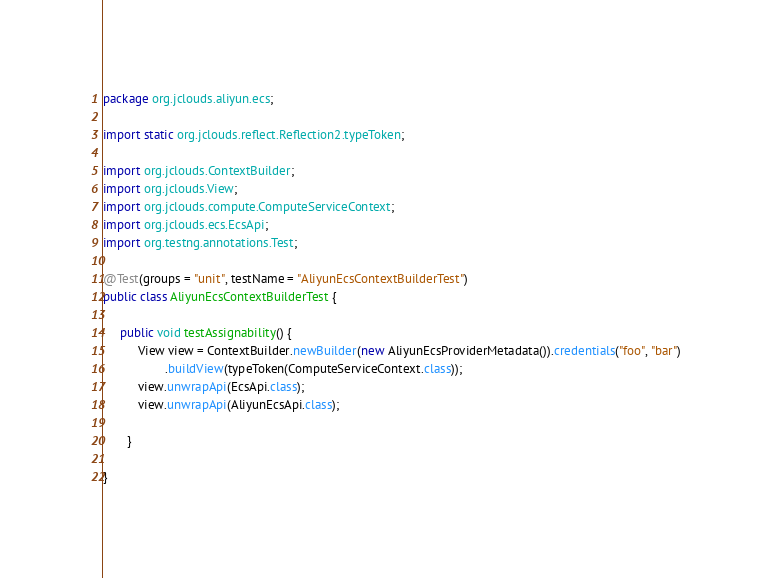Convert code to text. <code><loc_0><loc_0><loc_500><loc_500><_Java_>package org.jclouds.aliyun.ecs;

import static org.jclouds.reflect.Reflection2.typeToken;

import org.jclouds.ContextBuilder;
import org.jclouds.View;
import org.jclouds.compute.ComputeServiceContext;
import org.jclouds.ecs.EcsApi;
import org.testng.annotations.Test;

@Test(groups = "unit", testName = "AliyunEcsContextBuilderTest")
public class AliyunEcsContextBuilderTest {

	 public void testAssignability() {
	      View view = ContextBuilder.newBuilder(new AliyunEcsProviderMetadata()).credentials("foo", "bar")
	              .buildView(typeToken(ComputeServiceContext.class));
	      view.unwrapApi(EcsApi.class);
	      view.unwrapApi(AliyunEcsApi.class);
	      
	   }

}
</code> 